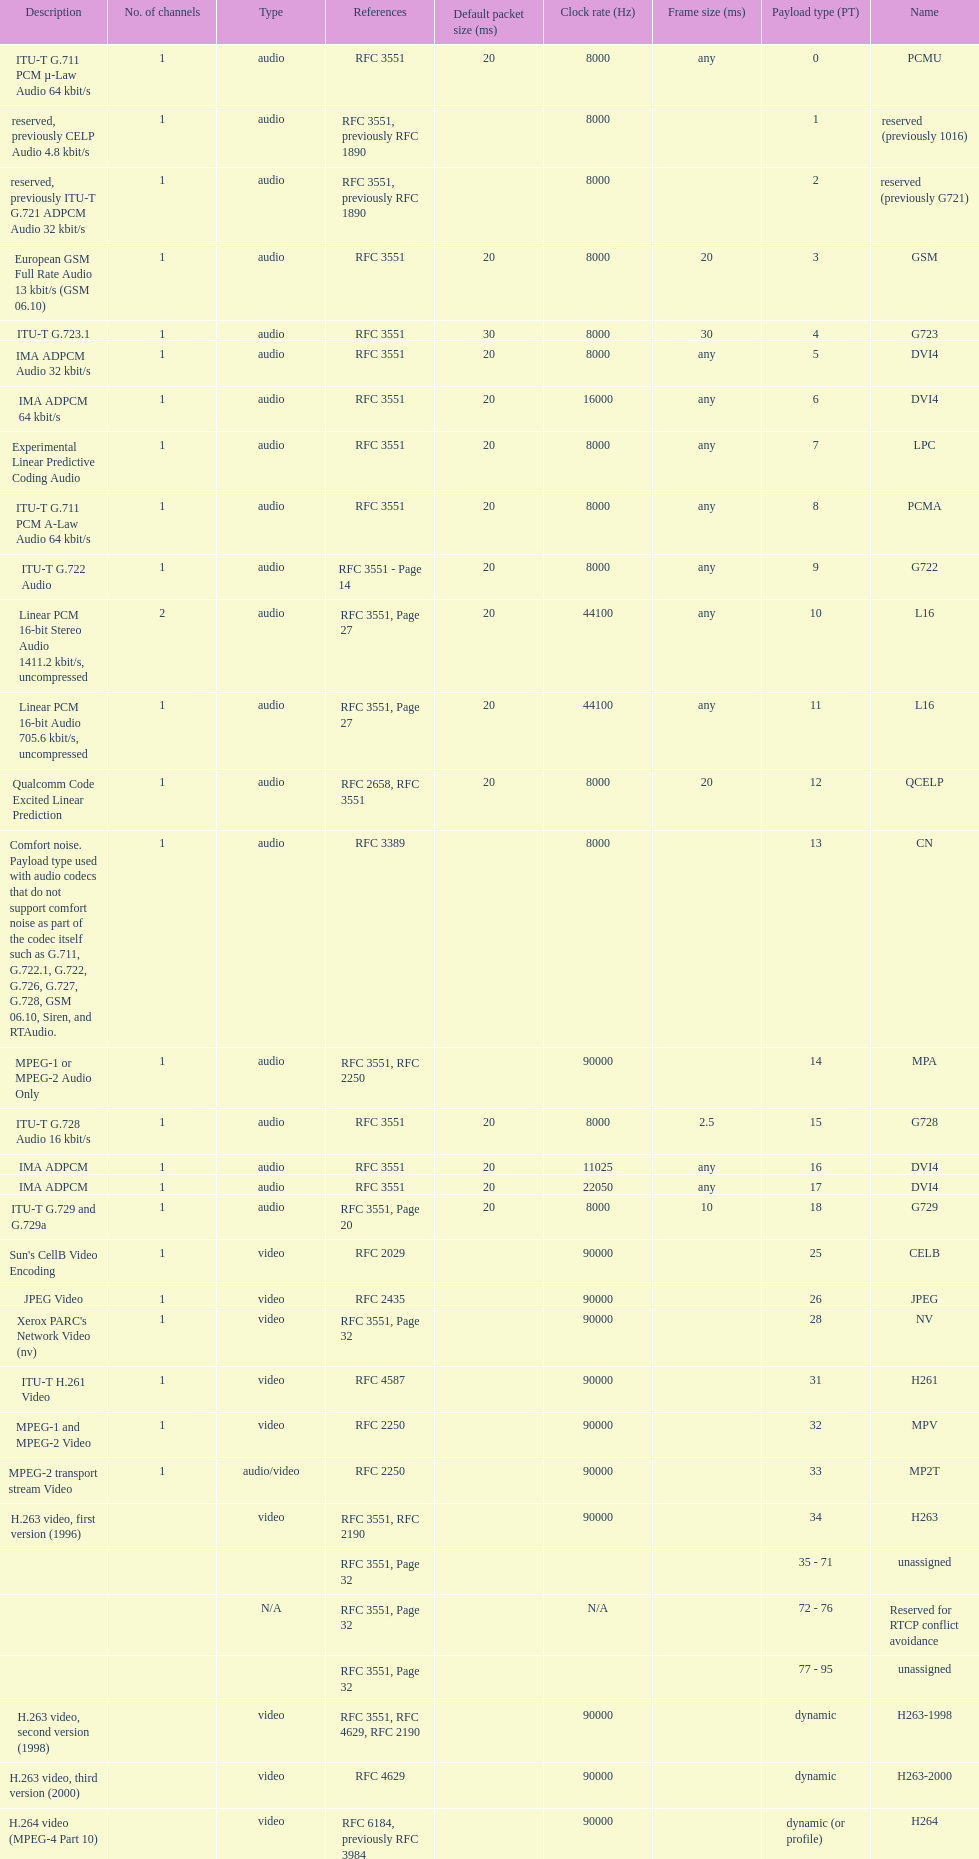The rtp/avp audio and video payload types include an audio type called qcelp and its frame size is how many ms? 20. Write the full table. {'header': ['Description', 'No. of channels', 'Type', 'References', 'Default packet size (ms)', 'Clock rate (Hz)', 'Frame size (ms)', 'Payload type (PT)', 'Name'], 'rows': [['ITU-T G.711 PCM µ-Law Audio 64\xa0kbit/s', '1', 'audio', 'RFC 3551', '20', '8000', 'any', '0', 'PCMU'], ['reserved, previously CELP Audio 4.8\xa0kbit/s', '1', 'audio', 'RFC 3551, previously RFC 1890', '', '8000', '', '1', 'reserved (previously 1016)'], ['reserved, previously ITU-T G.721 ADPCM Audio 32\xa0kbit/s', '1', 'audio', 'RFC 3551, previously RFC 1890', '', '8000', '', '2', 'reserved (previously G721)'], ['European GSM Full Rate Audio 13\xa0kbit/s (GSM 06.10)', '1', 'audio', 'RFC 3551', '20', '8000', '20', '3', 'GSM'], ['ITU-T G.723.1', '1', 'audio', 'RFC 3551', '30', '8000', '30', '4', 'G723'], ['IMA ADPCM Audio 32\xa0kbit/s', '1', 'audio', 'RFC 3551', '20', '8000', 'any', '5', 'DVI4'], ['IMA ADPCM 64\xa0kbit/s', '1', 'audio', 'RFC 3551', '20', '16000', 'any', '6', 'DVI4'], ['Experimental Linear Predictive Coding Audio', '1', 'audio', 'RFC 3551', '20', '8000', 'any', '7', 'LPC'], ['ITU-T G.711 PCM A-Law Audio 64\xa0kbit/s', '1', 'audio', 'RFC 3551', '20', '8000', 'any', '8', 'PCMA'], ['ITU-T G.722 Audio', '1', 'audio', 'RFC 3551 - Page 14', '20', '8000', 'any', '9', 'G722'], ['Linear PCM 16-bit Stereo Audio 1411.2\xa0kbit/s, uncompressed', '2', 'audio', 'RFC 3551, Page 27', '20', '44100', 'any', '10', 'L16'], ['Linear PCM 16-bit Audio 705.6\xa0kbit/s, uncompressed', '1', 'audio', 'RFC 3551, Page 27', '20', '44100', 'any', '11', 'L16'], ['Qualcomm Code Excited Linear Prediction', '1', 'audio', 'RFC 2658, RFC 3551', '20', '8000', '20', '12', 'QCELP'], ['Comfort noise. Payload type used with audio codecs that do not support comfort noise as part of the codec itself such as G.711, G.722.1, G.722, G.726, G.727, G.728, GSM 06.10, Siren, and RTAudio.', '1', 'audio', 'RFC 3389', '', '8000', '', '13', 'CN'], ['MPEG-1 or MPEG-2 Audio Only', '1', 'audio', 'RFC 3551, RFC 2250', '', '90000', '', '14', 'MPA'], ['ITU-T G.728 Audio 16\xa0kbit/s', '1', 'audio', 'RFC 3551', '20', '8000', '2.5', '15', 'G728'], ['IMA ADPCM', '1', 'audio', 'RFC 3551', '20', '11025', 'any', '16', 'DVI4'], ['IMA ADPCM', '1', 'audio', 'RFC 3551', '20', '22050', 'any', '17', 'DVI4'], ['ITU-T G.729 and G.729a', '1', 'audio', 'RFC 3551, Page 20', '20', '8000', '10', '18', 'G729'], ["Sun's CellB Video Encoding", '1', 'video', 'RFC 2029', '', '90000', '', '25', 'CELB'], ['JPEG Video', '1', 'video', 'RFC 2435', '', '90000', '', '26', 'JPEG'], ["Xerox PARC's Network Video (nv)", '1', 'video', 'RFC 3551, Page 32', '', '90000', '', '28', 'NV'], ['ITU-T H.261 Video', '1', 'video', 'RFC 4587', '', '90000', '', '31', 'H261'], ['MPEG-1 and MPEG-2 Video', '1', 'video', 'RFC 2250', '', '90000', '', '32', 'MPV'], ['MPEG-2 transport stream Video', '1', 'audio/video', 'RFC 2250', '', '90000', '', '33', 'MP2T'], ['H.263 video, first version (1996)', '', 'video', 'RFC 3551, RFC 2190', '', '90000', '', '34', 'H263'], ['', '', '', 'RFC 3551, Page 32', '', '', '', '35 - 71', 'unassigned'], ['', '', 'N/A', 'RFC 3551, Page 32', '', 'N/A', '', '72 - 76', 'Reserved for RTCP conflict avoidance'], ['', '', '', 'RFC 3551, Page 32', '', '', '', '77 - 95', 'unassigned'], ['H.263 video, second version (1998)', '', 'video', 'RFC 3551, RFC 4629, RFC 2190', '', '90000', '', 'dynamic', 'H263-1998'], ['H.263 video, third version (2000)', '', 'video', 'RFC 4629', '', '90000', '', 'dynamic', 'H263-2000'], ['H.264 video (MPEG-4 Part 10)', '', 'video', 'RFC 6184, previously RFC 3984', '', '90000', '', 'dynamic (or profile)', 'H264'], ['Theora video', '', 'video', 'draft-barbato-avt-rtp-theora-01', '', '90000', '', 'dynamic (or profile)', 'theora'], ['Internet low Bitrate Codec 13.33 or 15.2\xa0kbit/s', '1', 'audio', 'RFC 3952', '20 or 30, respectively', '8000', '20 or 30', 'dynamic', 'iLBC'], ['ITU-T G.711.1, A-law', '', 'audio', 'RFC 5391', '', '16000', '5', 'dynamic', 'PCMA-WB'], ['ITU-T G.711.1, µ-law', '', 'audio', 'RFC 5391', '', '16000', '5', 'dynamic', 'PCMU-WB'], ['ITU-T G.718', '', 'audio', 'draft-ietf-avt-rtp-g718-03', '', '32000 (placeholder)', '20', 'dynamic', 'G718'], ['ITU-T G.719', '(various)', 'audio', 'RFC 5404', '', '48000', '20', 'dynamic', 'G719'], ['ITU-T G.722.1', '', 'audio', 'RFC 5577', '', '32000, 16000', '20', 'dynamic', 'G7221'], ['ITU-T G.726 audio with 16\xa0kbit/s', '1', 'audio', 'RFC 3551', '20', '8000', 'any', 'dynamic', 'G726-16'], ['ITU-T G.726 audio with 24\xa0kbit/s', '1', 'audio', 'RFC 3551', '20', '8000', 'any', 'dynamic', 'G726-24'], ['ITU-T G.726 audio with 32\xa0kbit/s', '1', 'audio', 'RFC 3551', '20', '8000', 'any', 'dynamic', 'G726-32'], ['ITU-T G.726 audio with 40\xa0kbit/s', '1', 'audio', 'RFC 3551', '20', '8000', 'any', 'dynamic', 'G726-40'], ['ITU-T G.729 Annex D', '1', 'audio', 'RFC 3551', '20', '8000', '10', 'dynamic', 'G729D'], ['ITU-T G.729 Annex E', '1', 'audio', 'RFC 3551', '20', '8000', '10', 'dynamic', 'G729E'], ['ITU-T G.729.1', '', 'audio', 'RFC 4749', '', '16000', '20', 'dynamic', 'G7291'], ['ITU-T GSM-EFR (GSM 06.60)', '1', 'audio', 'RFC 3551', '20', '8000', '20', 'dynamic', 'GSM-EFR'], ['ITU-T GSM-HR (GSM 06.20)', '1', 'audio', 'RFC 5993', '', '8000', '20', 'dynamic', 'GSM-HR-08'], ['Adaptive Multi-Rate audio', '(various)', 'audio', 'RFC 4867', '', '8000', '20', 'dynamic (or profile)', 'AMR'], ['Adaptive Multi-Rate Wideband audio (ITU-T G.722.2)', '(various)', 'audio', 'RFC 4867', '', '16000', '20', 'dynamic (or profile)', 'AMR-WB'], ['Extended Adaptive Multi Rate – WideBand audio', '1, 2 or omit', 'audio', 'RFC 4352', '', '72000', '80 (super-frame; internally divided in to transport frames of 13.33, 14.22, 15, 16, 17.78, 20, 21.33, 24, 26.67, 30, 35.55, or 40)', 'dynamic (or profile)', 'AMR-WB+'], ['RTP Payload Format for Vorbis Encoded Audio', '(various)', 'audio', 'RFC 5215', "as many Vorbis packets as fit within the path MTU, unless it exceeds an application's desired transmission latency", 'any (must be a multiple of sample rate)', '', 'dynamic (or profile)', 'vorbis'], ['RTP Payload Format for Opus Speech and Audio Codec', '1, 2', 'audio', 'draft', '20, minimum allowed value 3 (rounded from 2.5), maximum allowed value 120 (allowed values are 3, 5, 10, 20, 40, or 60 or an arbitrary multiple of Opus frame sizes rounded up to the next full integer value up to a maximum value of 120)', '48000', '2.5, 5, 10, 20, 40, or 60', 'dynamic (or profile)', 'opus'], ['RTP Payload Format for the Speex Codec', '1', 'audio', 'RFC 5574', '', '8000, 16000 or 32000', '20', 'dynamic (or profile)', 'speex'], ['A More Loss-Tolerant RTP Payload Format for MP3 Audio', '', 'audio', 'RFC 5219', '', '90000', '', 'dynamic (96-127)', 'mpa-robust'], ['RTP Payload Format for MPEG-4 Audio', '', 'audio', 'RFC 6416 (previously RFC 3016)', 'recommended same as frame size', '90000 or others', '', 'dynamic (or profile)', 'MP4A-LATM'], ['RTP Payload Format for MPEG-4 Visual', '', 'video', 'RFC 6416 (previously RFC 3016)', 'recommended same as frame size', '90000 or others', '', 'dynamic (or profile)', 'MP4V-ES'], ['RTP Payload Format for Transport of MPEG-4 Elementary Streams', '', 'audio/video', 'RFC 3640', '', '90000 or other', '', 'dynamic (or profile)', 'mpeg4-generic'], ['RTP Payload Format for Transport of VP8 Streams', '', 'video', 'draft-ietf-payload-vp8-08', '', '90000', '', 'dynamic', 'VP8'], ['Linear PCM 8-bit audio with 128 offset', '(various)', 'audio', 'RFC 3551 Section 4.5.10 and Table 5', '20', '(various)', 'any', 'dynamic', 'L8'], ['IEC 61119 12-bit nonlinear audio', '(various)', 'audio', 'RFC 3190 Section 3', '20 (by analogy with L16)', '8000, 11025, 16000, 22050, 24000, 32000, 44100, 48000 or others', 'any', 'dynamic', 'DAT12'], ['Linear PCM 16-bit audio', '(various)', 'audio', 'RFC 3551 Section 4.5.11, RFC 2586', '20', '8000, 11025, 16000, 22050, 24000, 32000, 44100, 48000 or others', 'any', 'dynamic', 'L16'], ['Linear PCM 20-bit audio', '(various)', 'audio', 'RFC 3190 Section 4', '20 (by analogy with L16)', '8000, 11025, 16000, 22050, 24000, 32000, 44100, 48000 or others', 'any', 'dynamic', 'L20'], ['Linear PCM 24-bit audio', '(various)', 'audio', 'RFC 3190 Section 4', '20 (by analogy with L16)', '8000, 11025, 16000, 22050, 24000, 32000, 44100, 48000 or others', 'any', 'dynamic', 'L24']]} 